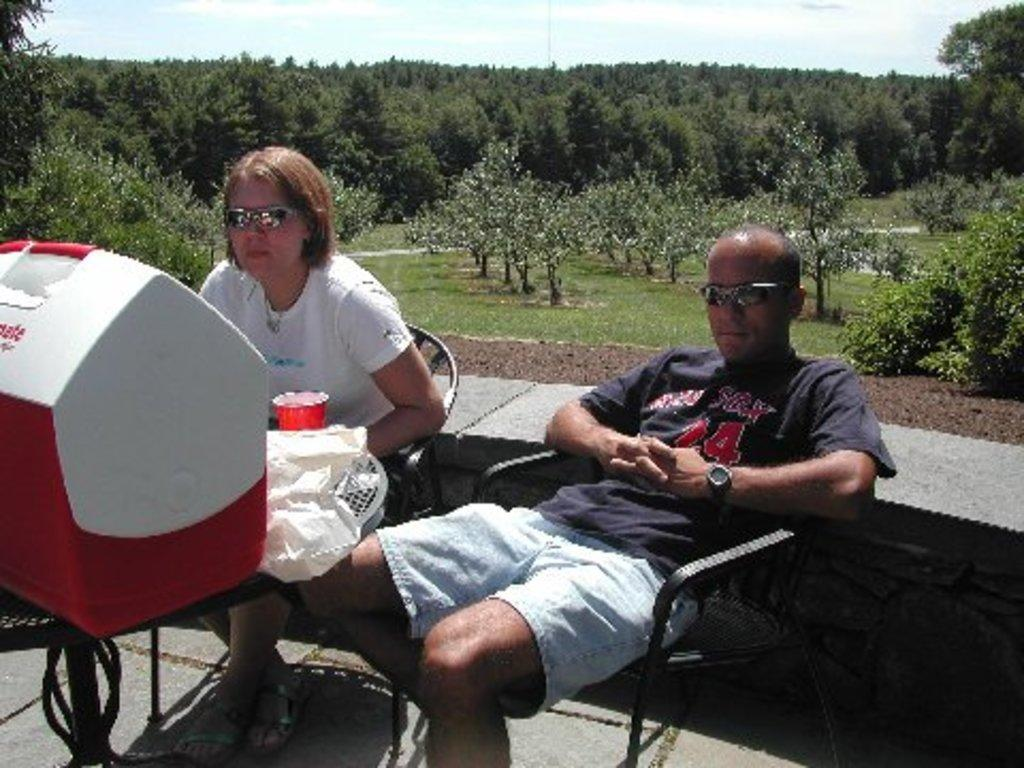What are the persons in the image doing? The persons in the image are sitting on chairs. What object can be seen in the image besides the chairs and persons? There is a box in the image. What can be seen in the background of the image? There are trees and the sky visible in the background of the image. How many apples are hanging from the trees in the image? There are no apples visible in the image; only trees can be seen in the background. 